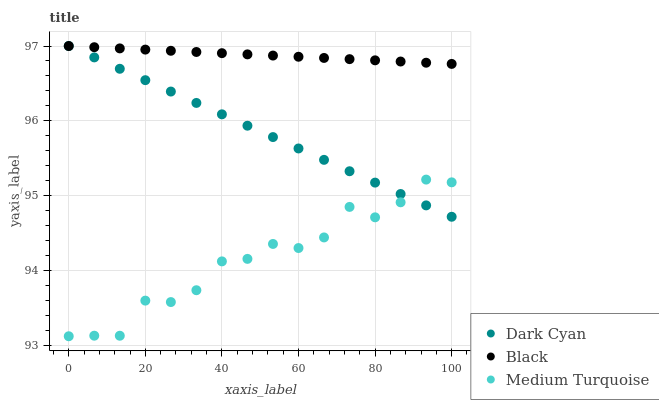Does Medium Turquoise have the minimum area under the curve?
Answer yes or no. Yes. Does Black have the maximum area under the curve?
Answer yes or no. Yes. Does Black have the minimum area under the curve?
Answer yes or no. No. Does Medium Turquoise have the maximum area under the curve?
Answer yes or no. No. Is Dark Cyan the smoothest?
Answer yes or no. Yes. Is Medium Turquoise the roughest?
Answer yes or no. Yes. Is Black the smoothest?
Answer yes or no. No. Is Black the roughest?
Answer yes or no. No. Does Medium Turquoise have the lowest value?
Answer yes or no. Yes. Does Black have the lowest value?
Answer yes or no. No. Does Black have the highest value?
Answer yes or no. Yes. Does Medium Turquoise have the highest value?
Answer yes or no. No. Is Medium Turquoise less than Black?
Answer yes or no. Yes. Is Black greater than Medium Turquoise?
Answer yes or no. Yes. Does Black intersect Dark Cyan?
Answer yes or no. Yes. Is Black less than Dark Cyan?
Answer yes or no. No. Is Black greater than Dark Cyan?
Answer yes or no. No. Does Medium Turquoise intersect Black?
Answer yes or no. No. 